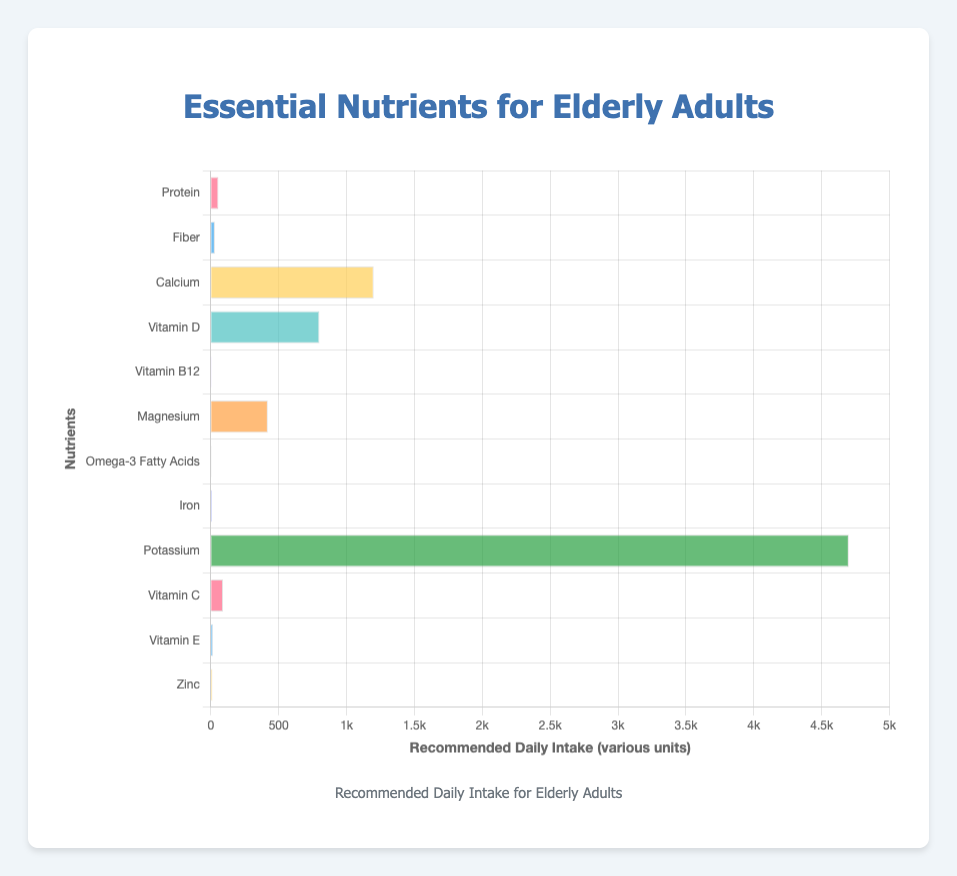What's the recommended daily intake for Protein? The chart shows the recommended daily intake values on the horizontal axis, aligned with the names of the nutrients on the vertical axis. Locate “Protein” on the vertical axis and check the corresponding value on the horizontal axis.
Answer: 56 g/day Which nutrient has the highest recommended daily intake? Examine the lengths of all bars along the horizontal axis. The longest bar represents the nutrient with the highest recommended daily intake.
Answer: Potassium How much more Potassium is recommended daily compared to Iron? Identify and compare the recommended daily intakes for Potassium (4700 mg/day) and Iron (8 mg/day). Subtract Iron’s intake from Potassium’s intake: 4700 - 8.
Answer: 4692 mg/day Which nutrient requires the least daily intake? Look for the shortest bar in the chart, as it represents the nutrient with the lowest recommended daily intake.
Answer: Vitamin B12 How does the recommended intake for Fiber compare to that for Omega-3 Fatty Acids? Compare the lengths of the bars for Fiber and Omega-3 Fatty Acids. Fiber has an intake of 30 g/day, while Omega-3 Fatty Acids have an intake of 1.5 g/day.
Answer: Fiber’s intake is higher What is the average recommended daily intake of Vitamin D, Calcium, and Magnesium? Sum the recommended daily intakes of Vitamin D (800 IU/day), Calcium (1200 mg/day), and Magnesium (420 mg/day). Then, divide by the number of nutrients (3): (800 + 1200 + 420) / 3.
Answer: 807 IU/mg/day Are there more nutrients with recommended intakes in grams than in milligrams? Count the number of nutrients with g/day units (Protein, Fiber, Omega-3 Fatty Acids) and compare it to those with mg/day units (Calcium, Magnesium, Iron, Potassium, Vitamin C, Vitamin E, Zinc).
Answer: No Which nutrients have a daily intake between 80 and 500 units? Identify the bars that fall within the numerical range of 80 to 500 units on the horizontal axis, which include units like mg/day and IU/day.
Answer: Magnesium, Vitamin C, Vitamin E What is the total recommended daily intake of Iron, Zinc, and Vitamin C? Add the recommended daily intakes for Iron (8 mg/day), Zinc (11 mg/day), and Vitamin C (90 mg/day): 8 + 11 + 90.
Answer: 109 mg/day Is the recommended intake for Vitamin E more than for Zinc? Compare the values of the recommended daily intake for Vitamin E and Zinc from the chart. Vitamin E is 15 mg/day, and Zinc is 11 mg/day.
Answer: Yes 